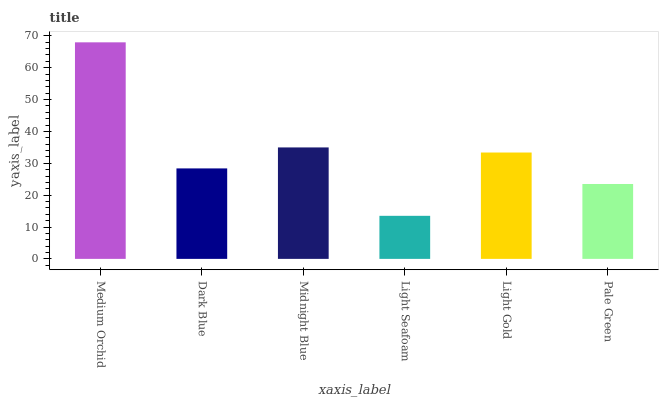Is Light Seafoam the minimum?
Answer yes or no. Yes. Is Medium Orchid the maximum?
Answer yes or no. Yes. Is Dark Blue the minimum?
Answer yes or no. No. Is Dark Blue the maximum?
Answer yes or no. No. Is Medium Orchid greater than Dark Blue?
Answer yes or no. Yes. Is Dark Blue less than Medium Orchid?
Answer yes or no. Yes. Is Dark Blue greater than Medium Orchid?
Answer yes or no. No. Is Medium Orchid less than Dark Blue?
Answer yes or no. No. Is Light Gold the high median?
Answer yes or no. Yes. Is Dark Blue the low median?
Answer yes or no. Yes. Is Midnight Blue the high median?
Answer yes or no. No. Is Light Seafoam the low median?
Answer yes or no. No. 